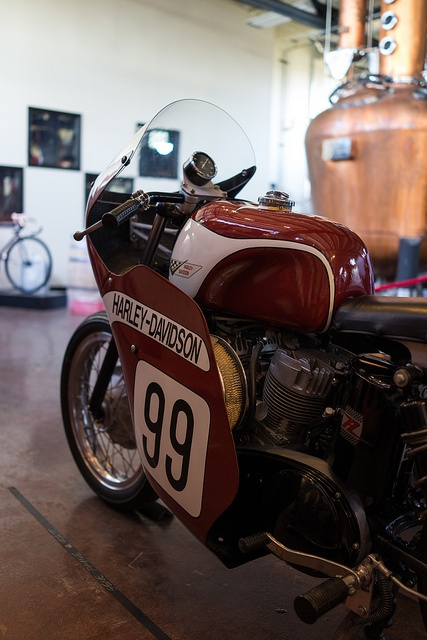Describe the objects in this image and their specific colors. I can see motorcycle in lightgray, black, maroon, and gray tones, tv in lightgray, gray, black, and blue tones, and bicycle in lightgray, lavender, and darkgray tones in this image. 